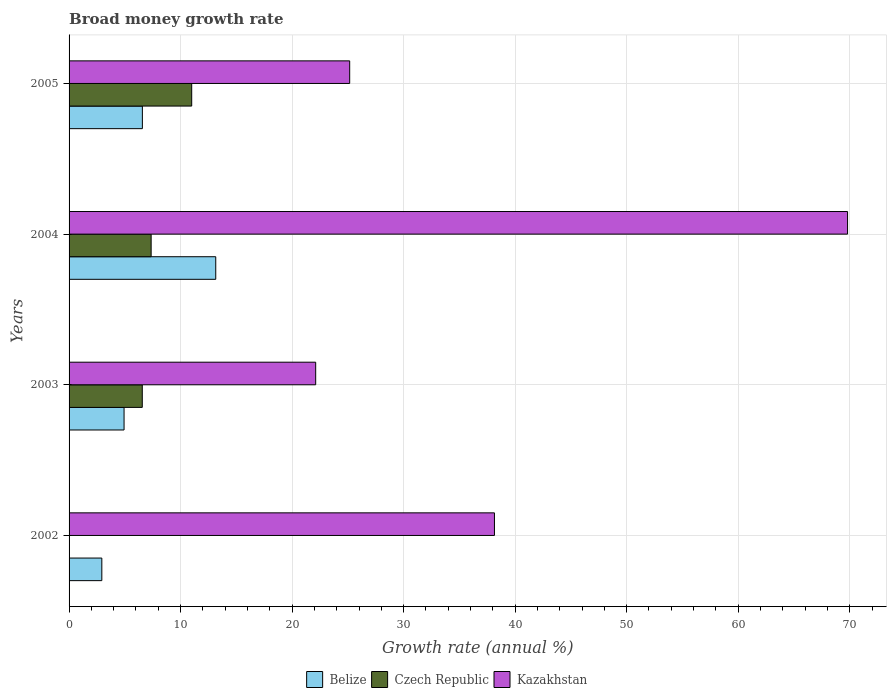How many bars are there on the 2nd tick from the top?
Make the answer very short. 3. What is the growth rate in Belize in 2004?
Provide a short and direct response. 13.15. Across all years, what is the maximum growth rate in Czech Republic?
Your answer should be very brief. 11. Across all years, what is the minimum growth rate in Czech Republic?
Keep it short and to the point. 0. In which year was the growth rate in Czech Republic maximum?
Your response must be concise. 2005. What is the total growth rate in Kazakhstan in the graph?
Make the answer very short. 155.23. What is the difference between the growth rate in Belize in 2004 and that in 2005?
Provide a short and direct response. 6.58. What is the difference between the growth rate in Belize in 2005 and the growth rate in Kazakhstan in 2002?
Ensure brevity in your answer.  -31.57. What is the average growth rate in Czech Republic per year?
Your answer should be compact. 6.23. In the year 2005, what is the difference between the growth rate in Czech Republic and growth rate in Kazakhstan?
Offer a terse response. -14.17. In how many years, is the growth rate in Belize greater than 16 %?
Your answer should be compact. 0. What is the ratio of the growth rate in Kazakhstan in 2004 to that in 2005?
Provide a short and direct response. 2.77. Is the difference between the growth rate in Czech Republic in 2003 and 2004 greater than the difference between the growth rate in Kazakhstan in 2003 and 2004?
Offer a terse response. Yes. What is the difference between the highest and the second highest growth rate in Czech Republic?
Provide a succinct answer. 3.64. What is the difference between the highest and the lowest growth rate in Czech Republic?
Your answer should be very brief. 11. Is the sum of the growth rate in Belize in 2002 and 2005 greater than the maximum growth rate in Czech Republic across all years?
Ensure brevity in your answer.  No. How many bars are there?
Provide a short and direct response. 11. How many years are there in the graph?
Your answer should be compact. 4. Are the values on the major ticks of X-axis written in scientific E-notation?
Give a very brief answer. No. Does the graph contain any zero values?
Provide a succinct answer. Yes. Does the graph contain grids?
Your answer should be compact. Yes. Where does the legend appear in the graph?
Offer a terse response. Bottom center. What is the title of the graph?
Keep it short and to the point. Broad money growth rate. Does "Caribbean small states" appear as one of the legend labels in the graph?
Give a very brief answer. No. What is the label or title of the X-axis?
Offer a terse response. Growth rate (annual %). What is the label or title of the Y-axis?
Your response must be concise. Years. What is the Growth rate (annual %) of Belize in 2002?
Offer a terse response. 2.94. What is the Growth rate (annual %) in Kazakhstan in 2002?
Provide a short and direct response. 38.15. What is the Growth rate (annual %) in Belize in 2003?
Offer a very short reply. 4.93. What is the Growth rate (annual %) in Czech Republic in 2003?
Your answer should be compact. 6.56. What is the Growth rate (annual %) of Kazakhstan in 2003?
Your answer should be very brief. 22.12. What is the Growth rate (annual %) in Belize in 2004?
Keep it short and to the point. 13.15. What is the Growth rate (annual %) in Czech Republic in 2004?
Provide a succinct answer. 7.36. What is the Growth rate (annual %) of Kazakhstan in 2004?
Your response must be concise. 69.81. What is the Growth rate (annual %) of Belize in 2005?
Provide a short and direct response. 6.57. What is the Growth rate (annual %) in Czech Republic in 2005?
Your answer should be compact. 11. What is the Growth rate (annual %) of Kazakhstan in 2005?
Provide a short and direct response. 25.16. Across all years, what is the maximum Growth rate (annual %) of Belize?
Keep it short and to the point. 13.15. Across all years, what is the maximum Growth rate (annual %) in Czech Republic?
Keep it short and to the point. 11. Across all years, what is the maximum Growth rate (annual %) of Kazakhstan?
Your answer should be compact. 69.81. Across all years, what is the minimum Growth rate (annual %) in Belize?
Offer a terse response. 2.94. Across all years, what is the minimum Growth rate (annual %) in Czech Republic?
Ensure brevity in your answer.  0. Across all years, what is the minimum Growth rate (annual %) of Kazakhstan?
Make the answer very short. 22.12. What is the total Growth rate (annual %) in Belize in the graph?
Offer a very short reply. 27.59. What is the total Growth rate (annual %) of Czech Republic in the graph?
Your answer should be compact. 24.92. What is the total Growth rate (annual %) in Kazakhstan in the graph?
Your answer should be very brief. 155.23. What is the difference between the Growth rate (annual %) in Belize in 2002 and that in 2003?
Give a very brief answer. -1.99. What is the difference between the Growth rate (annual %) in Kazakhstan in 2002 and that in 2003?
Provide a short and direct response. 16.03. What is the difference between the Growth rate (annual %) of Belize in 2002 and that in 2004?
Ensure brevity in your answer.  -10.22. What is the difference between the Growth rate (annual %) in Kazakhstan in 2002 and that in 2004?
Your answer should be compact. -31.66. What is the difference between the Growth rate (annual %) in Belize in 2002 and that in 2005?
Provide a succinct answer. -3.64. What is the difference between the Growth rate (annual %) of Kazakhstan in 2002 and that in 2005?
Provide a short and direct response. 12.98. What is the difference between the Growth rate (annual %) in Belize in 2003 and that in 2004?
Your answer should be very brief. -8.22. What is the difference between the Growth rate (annual %) of Czech Republic in 2003 and that in 2004?
Your answer should be compact. -0.79. What is the difference between the Growth rate (annual %) of Kazakhstan in 2003 and that in 2004?
Your response must be concise. -47.69. What is the difference between the Growth rate (annual %) of Belize in 2003 and that in 2005?
Provide a short and direct response. -1.64. What is the difference between the Growth rate (annual %) in Czech Republic in 2003 and that in 2005?
Your answer should be compact. -4.43. What is the difference between the Growth rate (annual %) in Kazakhstan in 2003 and that in 2005?
Your answer should be very brief. -3.05. What is the difference between the Growth rate (annual %) in Belize in 2004 and that in 2005?
Your response must be concise. 6.58. What is the difference between the Growth rate (annual %) of Czech Republic in 2004 and that in 2005?
Your answer should be very brief. -3.64. What is the difference between the Growth rate (annual %) of Kazakhstan in 2004 and that in 2005?
Ensure brevity in your answer.  44.64. What is the difference between the Growth rate (annual %) in Belize in 2002 and the Growth rate (annual %) in Czech Republic in 2003?
Offer a very short reply. -3.63. What is the difference between the Growth rate (annual %) of Belize in 2002 and the Growth rate (annual %) of Kazakhstan in 2003?
Keep it short and to the point. -19.18. What is the difference between the Growth rate (annual %) in Belize in 2002 and the Growth rate (annual %) in Czech Republic in 2004?
Make the answer very short. -4.42. What is the difference between the Growth rate (annual %) of Belize in 2002 and the Growth rate (annual %) of Kazakhstan in 2004?
Your response must be concise. -66.87. What is the difference between the Growth rate (annual %) of Belize in 2002 and the Growth rate (annual %) of Czech Republic in 2005?
Ensure brevity in your answer.  -8.06. What is the difference between the Growth rate (annual %) of Belize in 2002 and the Growth rate (annual %) of Kazakhstan in 2005?
Offer a terse response. -22.23. What is the difference between the Growth rate (annual %) of Belize in 2003 and the Growth rate (annual %) of Czech Republic in 2004?
Provide a short and direct response. -2.43. What is the difference between the Growth rate (annual %) of Belize in 2003 and the Growth rate (annual %) of Kazakhstan in 2004?
Give a very brief answer. -64.88. What is the difference between the Growth rate (annual %) in Czech Republic in 2003 and the Growth rate (annual %) in Kazakhstan in 2004?
Keep it short and to the point. -63.24. What is the difference between the Growth rate (annual %) of Belize in 2003 and the Growth rate (annual %) of Czech Republic in 2005?
Offer a terse response. -6.07. What is the difference between the Growth rate (annual %) of Belize in 2003 and the Growth rate (annual %) of Kazakhstan in 2005?
Provide a succinct answer. -20.23. What is the difference between the Growth rate (annual %) of Czech Republic in 2003 and the Growth rate (annual %) of Kazakhstan in 2005?
Keep it short and to the point. -18.6. What is the difference between the Growth rate (annual %) of Belize in 2004 and the Growth rate (annual %) of Czech Republic in 2005?
Provide a succinct answer. 2.16. What is the difference between the Growth rate (annual %) of Belize in 2004 and the Growth rate (annual %) of Kazakhstan in 2005?
Make the answer very short. -12.01. What is the difference between the Growth rate (annual %) in Czech Republic in 2004 and the Growth rate (annual %) in Kazakhstan in 2005?
Provide a succinct answer. -17.8. What is the average Growth rate (annual %) in Belize per year?
Offer a terse response. 6.9. What is the average Growth rate (annual %) in Czech Republic per year?
Provide a short and direct response. 6.23. What is the average Growth rate (annual %) in Kazakhstan per year?
Ensure brevity in your answer.  38.81. In the year 2002, what is the difference between the Growth rate (annual %) in Belize and Growth rate (annual %) in Kazakhstan?
Offer a very short reply. -35.21. In the year 2003, what is the difference between the Growth rate (annual %) of Belize and Growth rate (annual %) of Czech Republic?
Your answer should be compact. -1.63. In the year 2003, what is the difference between the Growth rate (annual %) of Belize and Growth rate (annual %) of Kazakhstan?
Offer a very short reply. -17.18. In the year 2003, what is the difference between the Growth rate (annual %) in Czech Republic and Growth rate (annual %) in Kazakhstan?
Your answer should be very brief. -15.55. In the year 2004, what is the difference between the Growth rate (annual %) in Belize and Growth rate (annual %) in Czech Republic?
Give a very brief answer. 5.79. In the year 2004, what is the difference between the Growth rate (annual %) in Belize and Growth rate (annual %) in Kazakhstan?
Your answer should be very brief. -56.66. In the year 2004, what is the difference between the Growth rate (annual %) of Czech Republic and Growth rate (annual %) of Kazakhstan?
Make the answer very short. -62.45. In the year 2005, what is the difference between the Growth rate (annual %) in Belize and Growth rate (annual %) in Czech Republic?
Make the answer very short. -4.42. In the year 2005, what is the difference between the Growth rate (annual %) of Belize and Growth rate (annual %) of Kazakhstan?
Ensure brevity in your answer.  -18.59. In the year 2005, what is the difference between the Growth rate (annual %) of Czech Republic and Growth rate (annual %) of Kazakhstan?
Give a very brief answer. -14.17. What is the ratio of the Growth rate (annual %) in Belize in 2002 to that in 2003?
Provide a short and direct response. 0.6. What is the ratio of the Growth rate (annual %) in Kazakhstan in 2002 to that in 2003?
Offer a terse response. 1.72. What is the ratio of the Growth rate (annual %) of Belize in 2002 to that in 2004?
Ensure brevity in your answer.  0.22. What is the ratio of the Growth rate (annual %) of Kazakhstan in 2002 to that in 2004?
Offer a terse response. 0.55. What is the ratio of the Growth rate (annual %) in Belize in 2002 to that in 2005?
Ensure brevity in your answer.  0.45. What is the ratio of the Growth rate (annual %) of Kazakhstan in 2002 to that in 2005?
Ensure brevity in your answer.  1.52. What is the ratio of the Growth rate (annual %) of Belize in 2003 to that in 2004?
Make the answer very short. 0.37. What is the ratio of the Growth rate (annual %) in Czech Republic in 2003 to that in 2004?
Your answer should be very brief. 0.89. What is the ratio of the Growth rate (annual %) in Kazakhstan in 2003 to that in 2004?
Provide a succinct answer. 0.32. What is the ratio of the Growth rate (annual %) in Belize in 2003 to that in 2005?
Your answer should be compact. 0.75. What is the ratio of the Growth rate (annual %) of Czech Republic in 2003 to that in 2005?
Make the answer very short. 0.6. What is the ratio of the Growth rate (annual %) in Kazakhstan in 2003 to that in 2005?
Offer a terse response. 0.88. What is the ratio of the Growth rate (annual %) in Belize in 2004 to that in 2005?
Ensure brevity in your answer.  2. What is the ratio of the Growth rate (annual %) in Czech Republic in 2004 to that in 2005?
Provide a short and direct response. 0.67. What is the ratio of the Growth rate (annual %) of Kazakhstan in 2004 to that in 2005?
Give a very brief answer. 2.77. What is the difference between the highest and the second highest Growth rate (annual %) in Belize?
Provide a short and direct response. 6.58. What is the difference between the highest and the second highest Growth rate (annual %) in Czech Republic?
Ensure brevity in your answer.  3.64. What is the difference between the highest and the second highest Growth rate (annual %) of Kazakhstan?
Your response must be concise. 31.66. What is the difference between the highest and the lowest Growth rate (annual %) in Belize?
Offer a terse response. 10.22. What is the difference between the highest and the lowest Growth rate (annual %) in Czech Republic?
Offer a terse response. 11. What is the difference between the highest and the lowest Growth rate (annual %) in Kazakhstan?
Your response must be concise. 47.69. 